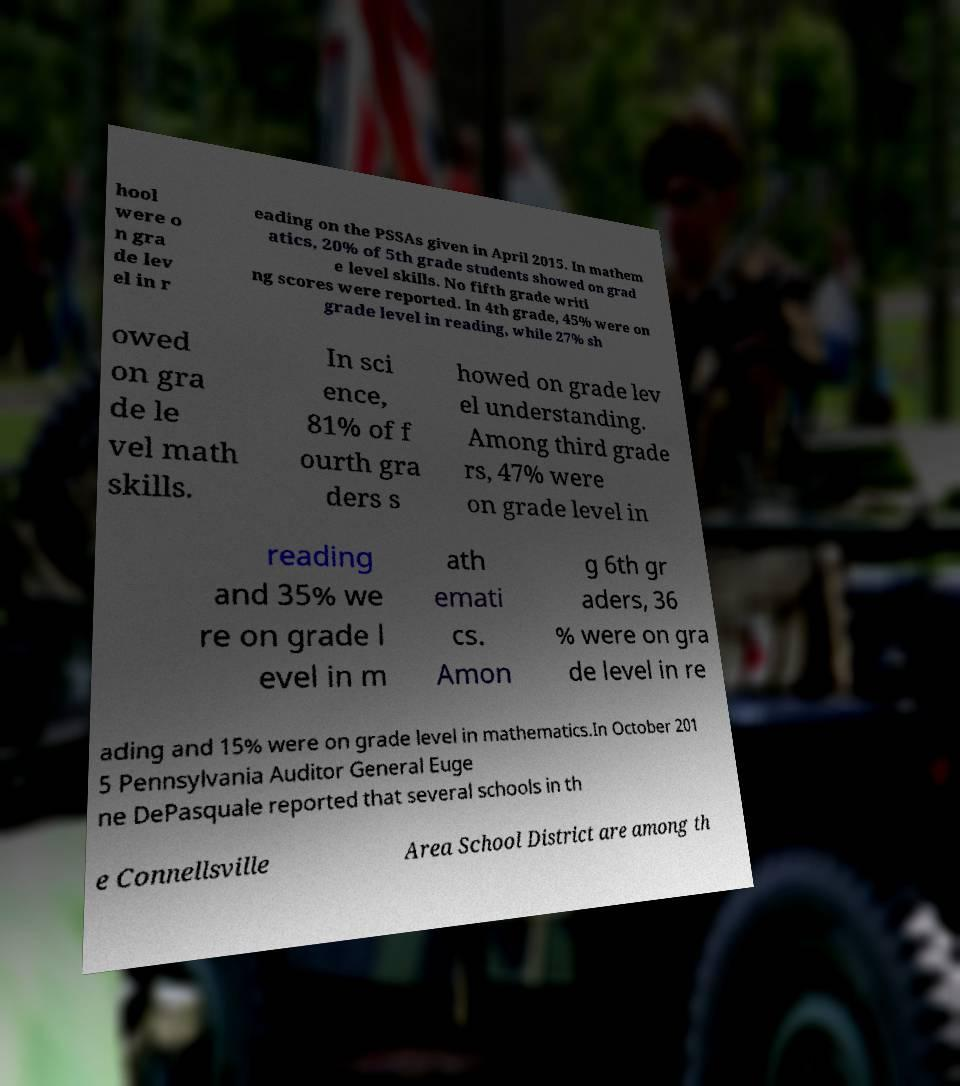Can you accurately transcribe the text from the provided image for me? hool were o n gra de lev el in r eading on the PSSAs given in April 2015. In mathem atics, 20% of 5th grade students showed on grad e level skills. No fifth grade writi ng scores were reported. In 4th grade, 45% were on grade level in reading, while 27% sh owed on gra de le vel math skills. In sci ence, 81% of f ourth gra ders s howed on grade lev el understanding. Among third grade rs, 47% were on grade level in reading and 35% we re on grade l evel in m ath emati cs. Amon g 6th gr aders, 36 % were on gra de level in re ading and 15% were on grade level in mathematics.In October 201 5 Pennsylvania Auditor General Euge ne DePasquale reported that several schools in th e Connellsville Area School District are among th 